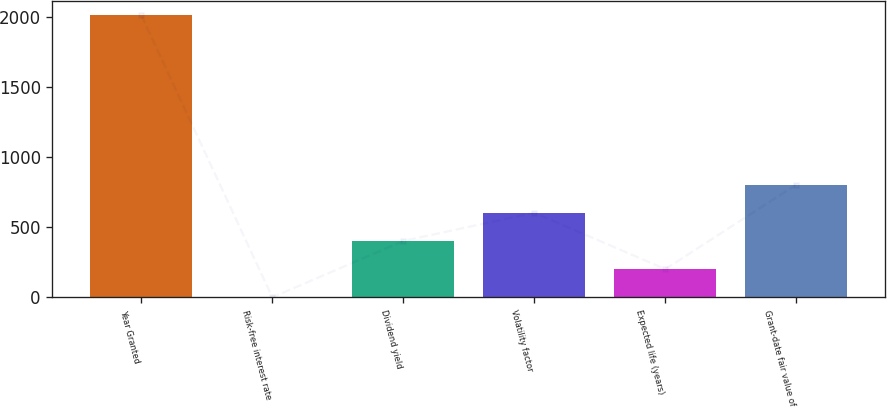Convert chart to OTSL. <chart><loc_0><loc_0><loc_500><loc_500><bar_chart><fcel>Year Granted<fcel>Risk-free interest rate<fcel>Dividend yield<fcel>Volatility factor<fcel>Expected life (years)<fcel>Grant-date fair value of<nl><fcel>2015<fcel>0.9<fcel>403.72<fcel>605.13<fcel>202.31<fcel>806.54<nl></chart> 